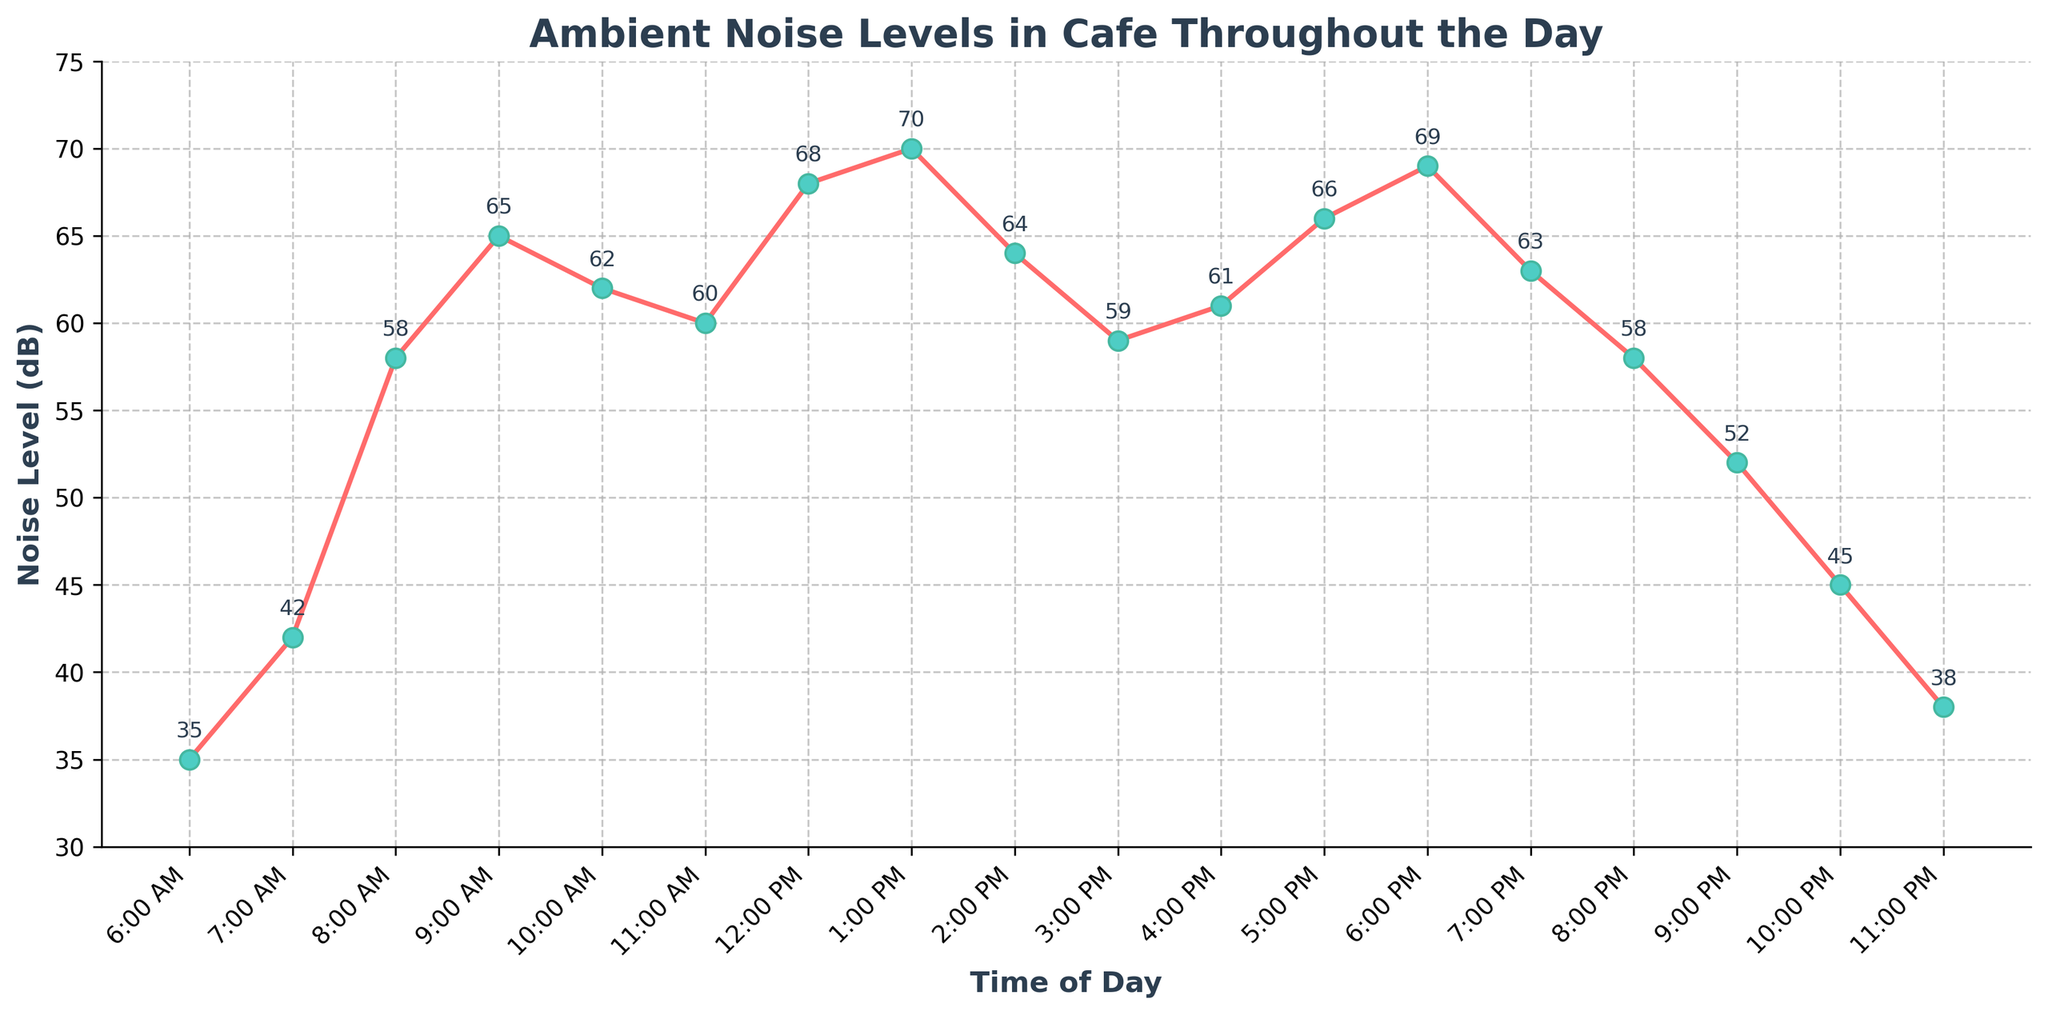What times of the day have the highest and lowest noise levels? To find the highest noise level, look at the peak point on the line chart, which occurs at 1:00 PM (70 dB). The lowest noise level can be found at the lowest point, which occurs at 6:00 AM (35 dB).
Answer: 1:00 PM and 6:00 AM How much does the noise level decrease from 1:00 PM to 2:00 PM? Locate the noise level at 1:00 PM (70 dB) and 2:00 PM (64 dB). Subtract 64 dB from 70 dB to find the decrease.
Answer: 6 dB What is the range of the noise levels throughout the day? The range is the difference between the highest and lowest noise levels. The highest is 70 dB at 1:00 PM, and the lowest is 35 dB at 6:00 AM. Subtract 35 from 70.
Answer: 35 dB What time shows the most significant increase in noise level compared to the previous hour? Examine the differences between consecutive points. The largest increase occurs between 7:00 AM (42 dB) and 8:00 AM (58 dB). Subtract 42 dB from 58 dB.
Answer: 8:00 AM How does the noise level change between 10:00 PM and 11:00 PM? Check the noise levels at 10:00 PM (45 dB) and 11:00 PM (38 dB). There is a decrease from 45 dB to 38 dB.
Answer: It decreases During which time intervals does the noise level remain consistent or nearly consistent? Compare noise levels between consecutive times to find intervals with little to no change. The levels are nearly consistent between 10:00 AM (62 dB), 11:00 AM (60 dB), and 12:00 PM (68 dB).
Answer: 10:00 AM to 12:00 PM What is the average noise level between 6:00 AM and 12:00 PM? Sum the noise levels from 6:00 AM (35), 7:00 AM (42), 8:00 AM (58), 9:00 AM (65), 10:00 AM (62), 11:00 AM (60), and 12:00 PM (68), then divide by 7. (35+42+58+65+62+60+68) / 7 = 390 / 7 = 55.71
Answer: 55.71 dB Which time of the day experiences a noise level of 61 dB? Look at the data points to find when the noise level is 61 dB. It occurs at 4:00 PM.
Answer: 4:00 PM Is the noise level at 9:00 PM higher or lower compared to 8:00 PM? Compare the noise level at 9:00 PM (52 dB) to 8:00 PM (58 dB).
Answer: Lower Between which hours does the noise level peak in the afternoon? Observe the line chart in the afternoon hours. The peak noise level occurs at 1:00 PM (70 dB).
Answer: 1:00 PM 